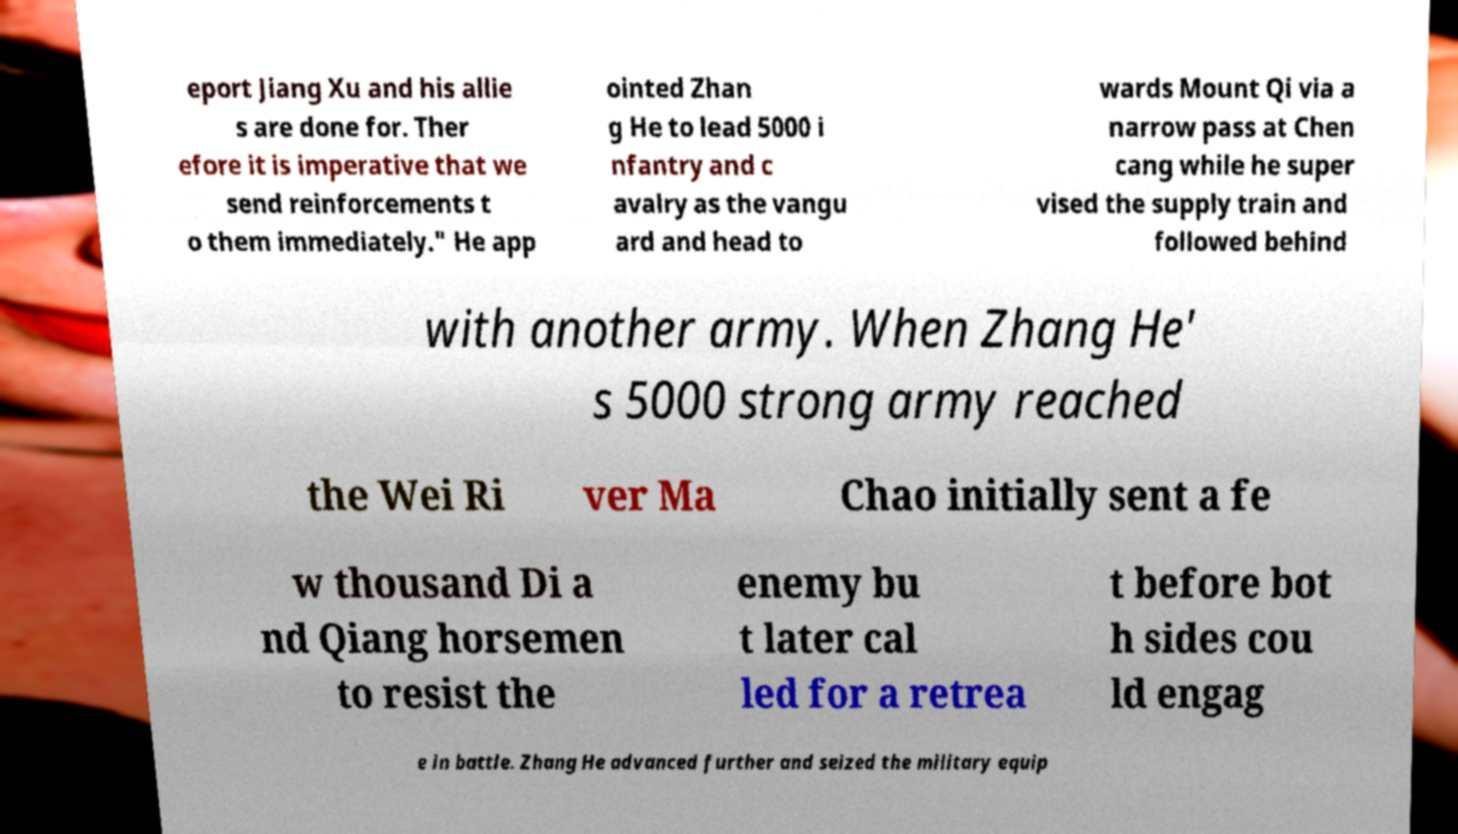Please identify and transcribe the text found in this image. eport Jiang Xu and his allie s are done for. Ther efore it is imperative that we send reinforcements t o them immediately." He app ointed Zhan g He to lead 5000 i nfantry and c avalry as the vangu ard and head to wards Mount Qi via a narrow pass at Chen cang while he super vised the supply train and followed behind with another army. When Zhang He' s 5000 strong army reached the Wei Ri ver Ma Chao initially sent a fe w thousand Di a nd Qiang horsemen to resist the enemy bu t later cal led for a retrea t before bot h sides cou ld engag e in battle. Zhang He advanced further and seized the military equip 